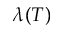<formula> <loc_0><loc_0><loc_500><loc_500>\lambda ( T )</formula> 